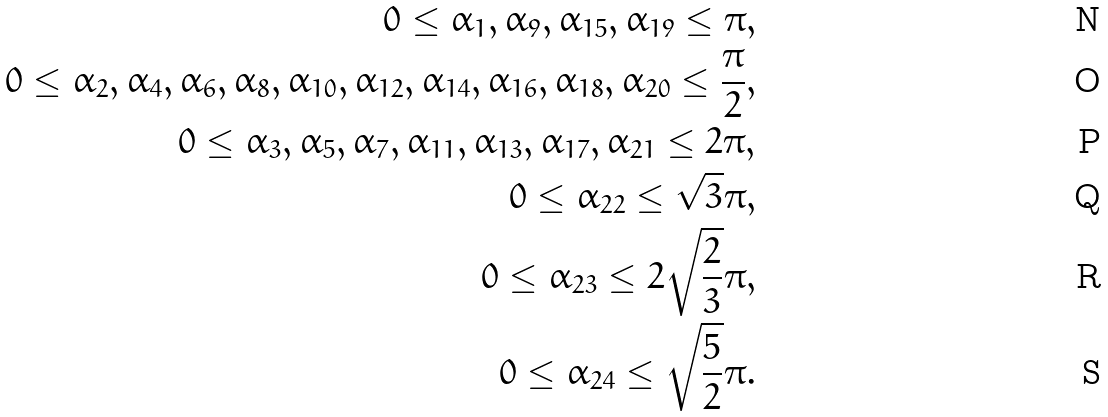Convert formula to latex. <formula><loc_0><loc_0><loc_500><loc_500>0 \leq \alpha _ { 1 } , \alpha _ { 9 } , \alpha _ { 1 5 } , \alpha _ { 1 9 } \leq \pi , \\ 0 \leq \alpha _ { 2 } , \alpha _ { 4 } , \alpha _ { 6 } , \alpha _ { 8 } , \alpha _ { 1 0 } , \alpha _ { 1 2 } , \alpha _ { 1 4 } , \alpha _ { 1 6 } , \alpha _ { 1 8 } , \alpha _ { 2 0 } \leq \frac { \pi } { 2 } , \\ 0 \leq \alpha _ { 3 } , \alpha _ { 5 } , \alpha _ { 7 } , \alpha _ { 1 1 } , \alpha _ { 1 3 } , \alpha _ { 1 7 } , \alpha _ { 2 1 } \leq 2 \pi , \\ 0 \leq \alpha _ { 2 2 } \leq \sqrt { 3 } \pi , \\ 0 \leq \alpha _ { 2 3 } \leq 2 \sqrt { \frac { 2 } { 3 } } \pi , \\ 0 \leq \alpha _ { 2 4 } \leq \sqrt { \frac { 5 } { 2 } } \pi .</formula> 